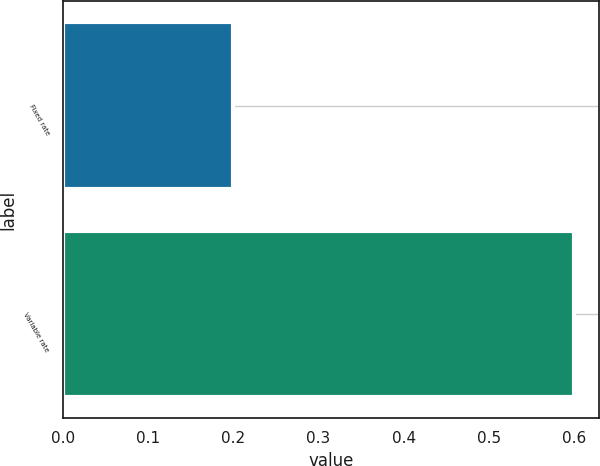<chart> <loc_0><loc_0><loc_500><loc_500><bar_chart><fcel>Fixed rate<fcel>Variable rate<nl><fcel>0.2<fcel>0.6<nl></chart> 